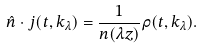Convert formula to latex. <formula><loc_0><loc_0><loc_500><loc_500>\hat { n } \cdot j ( t , k _ { \lambda } ) = \frac { 1 } { n ( \lambda z ) } \rho ( t , k _ { \lambda } ) .</formula> 